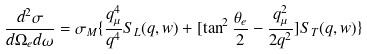Convert formula to latex. <formula><loc_0><loc_0><loc_500><loc_500>\frac { d ^ { 2 } \sigma } { d \Omega _ { e } d \omega } = \sigma _ { M } \{ \frac { q ^ { 4 } _ { \mu } } { q ^ { 4 } } S _ { L } ( q , w ) + [ \tan ^ { 2 } \frac { \theta _ { e } } { 2 } - \frac { q ^ { 2 } _ { \mu } } { 2 q ^ { 2 } } ] S _ { T } ( q , w ) \}</formula> 